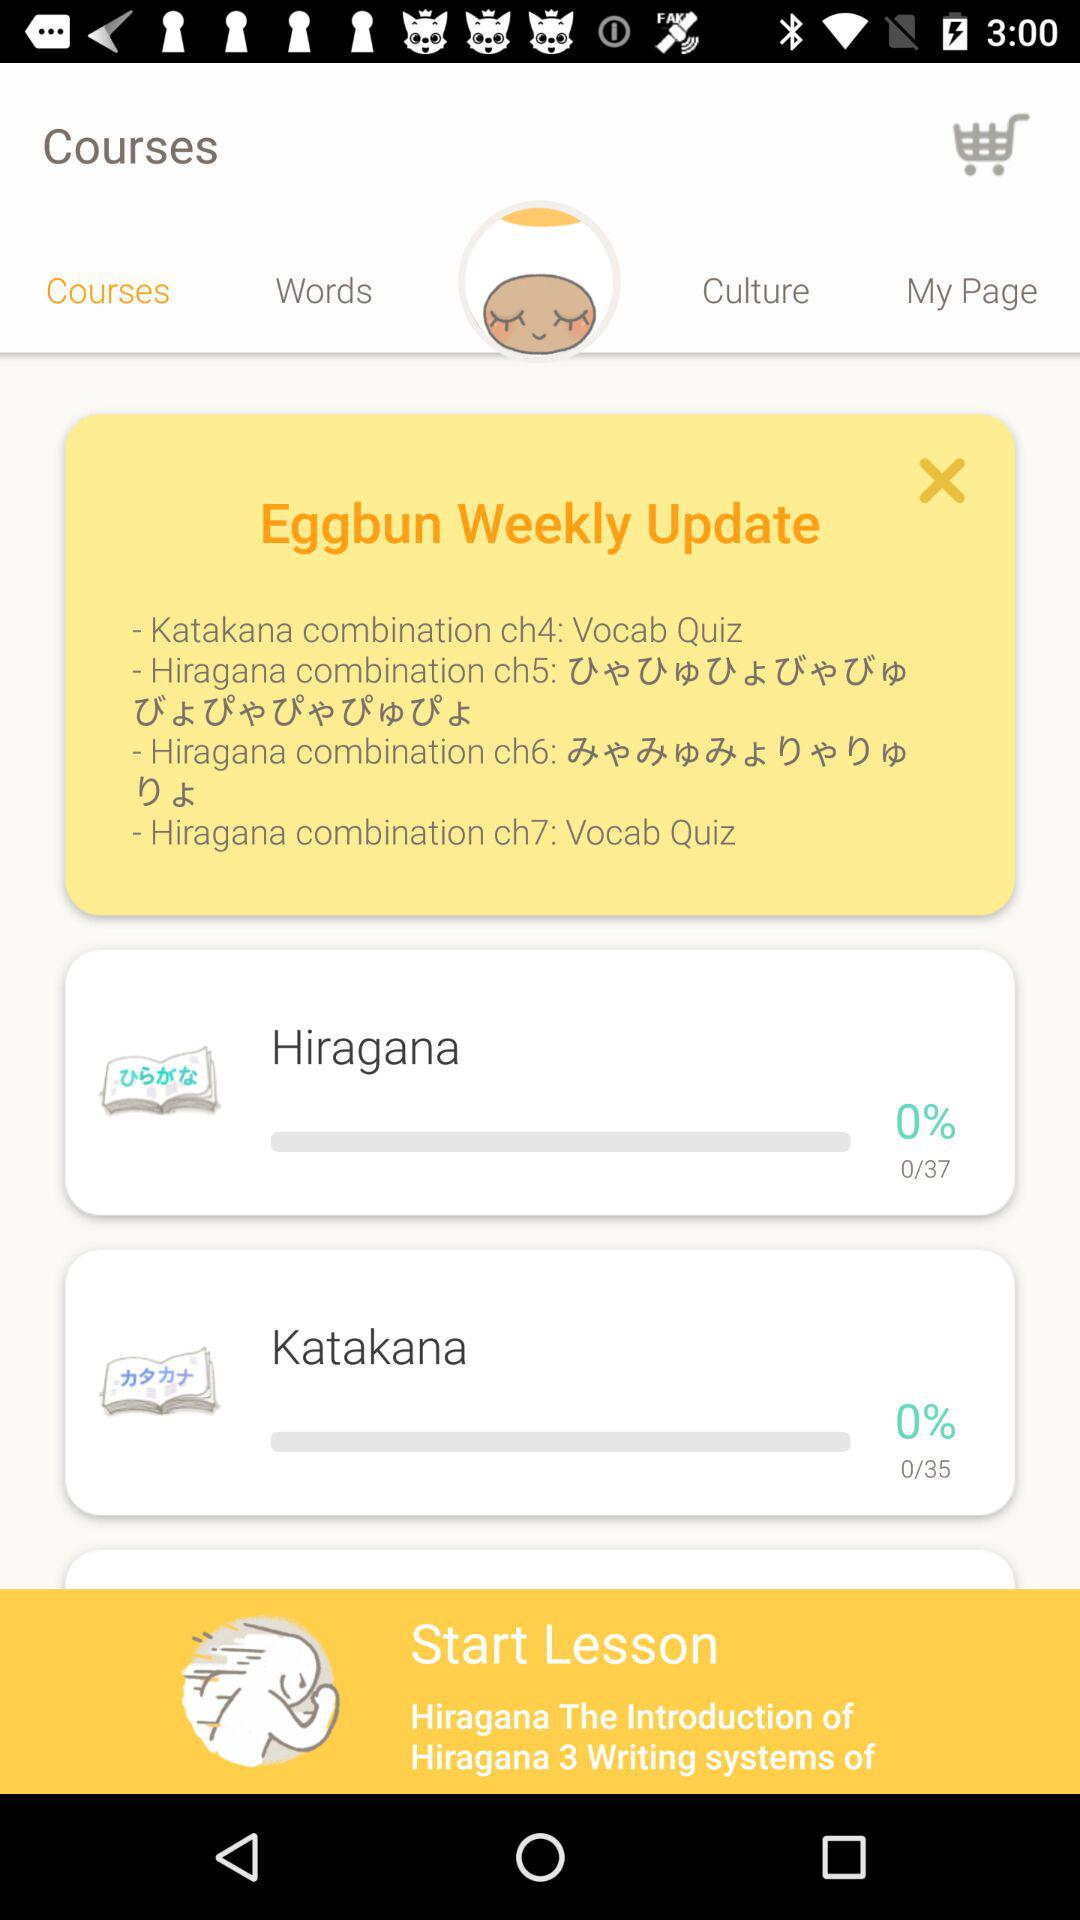How many more lessons are there in Hiragana than in Katakana?
Answer the question using a single word or phrase. 2 